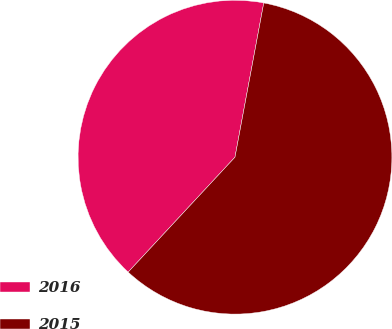<chart> <loc_0><loc_0><loc_500><loc_500><pie_chart><fcel>2016<fcel>2015<nl><fcel>41.02%<fcel>58.98%<nl></chart> 